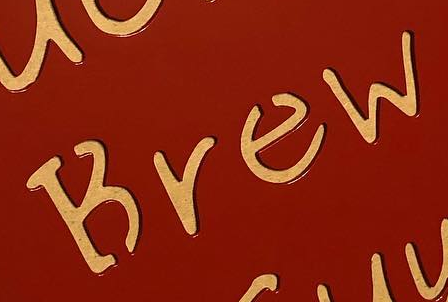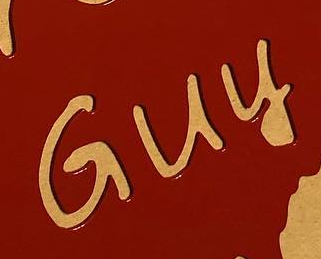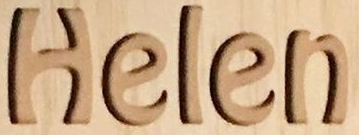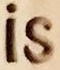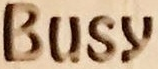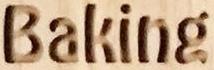Read the text content from these images in order, separated by a semicolon. Brew; Guy; Helen; is; Busy; Baking 